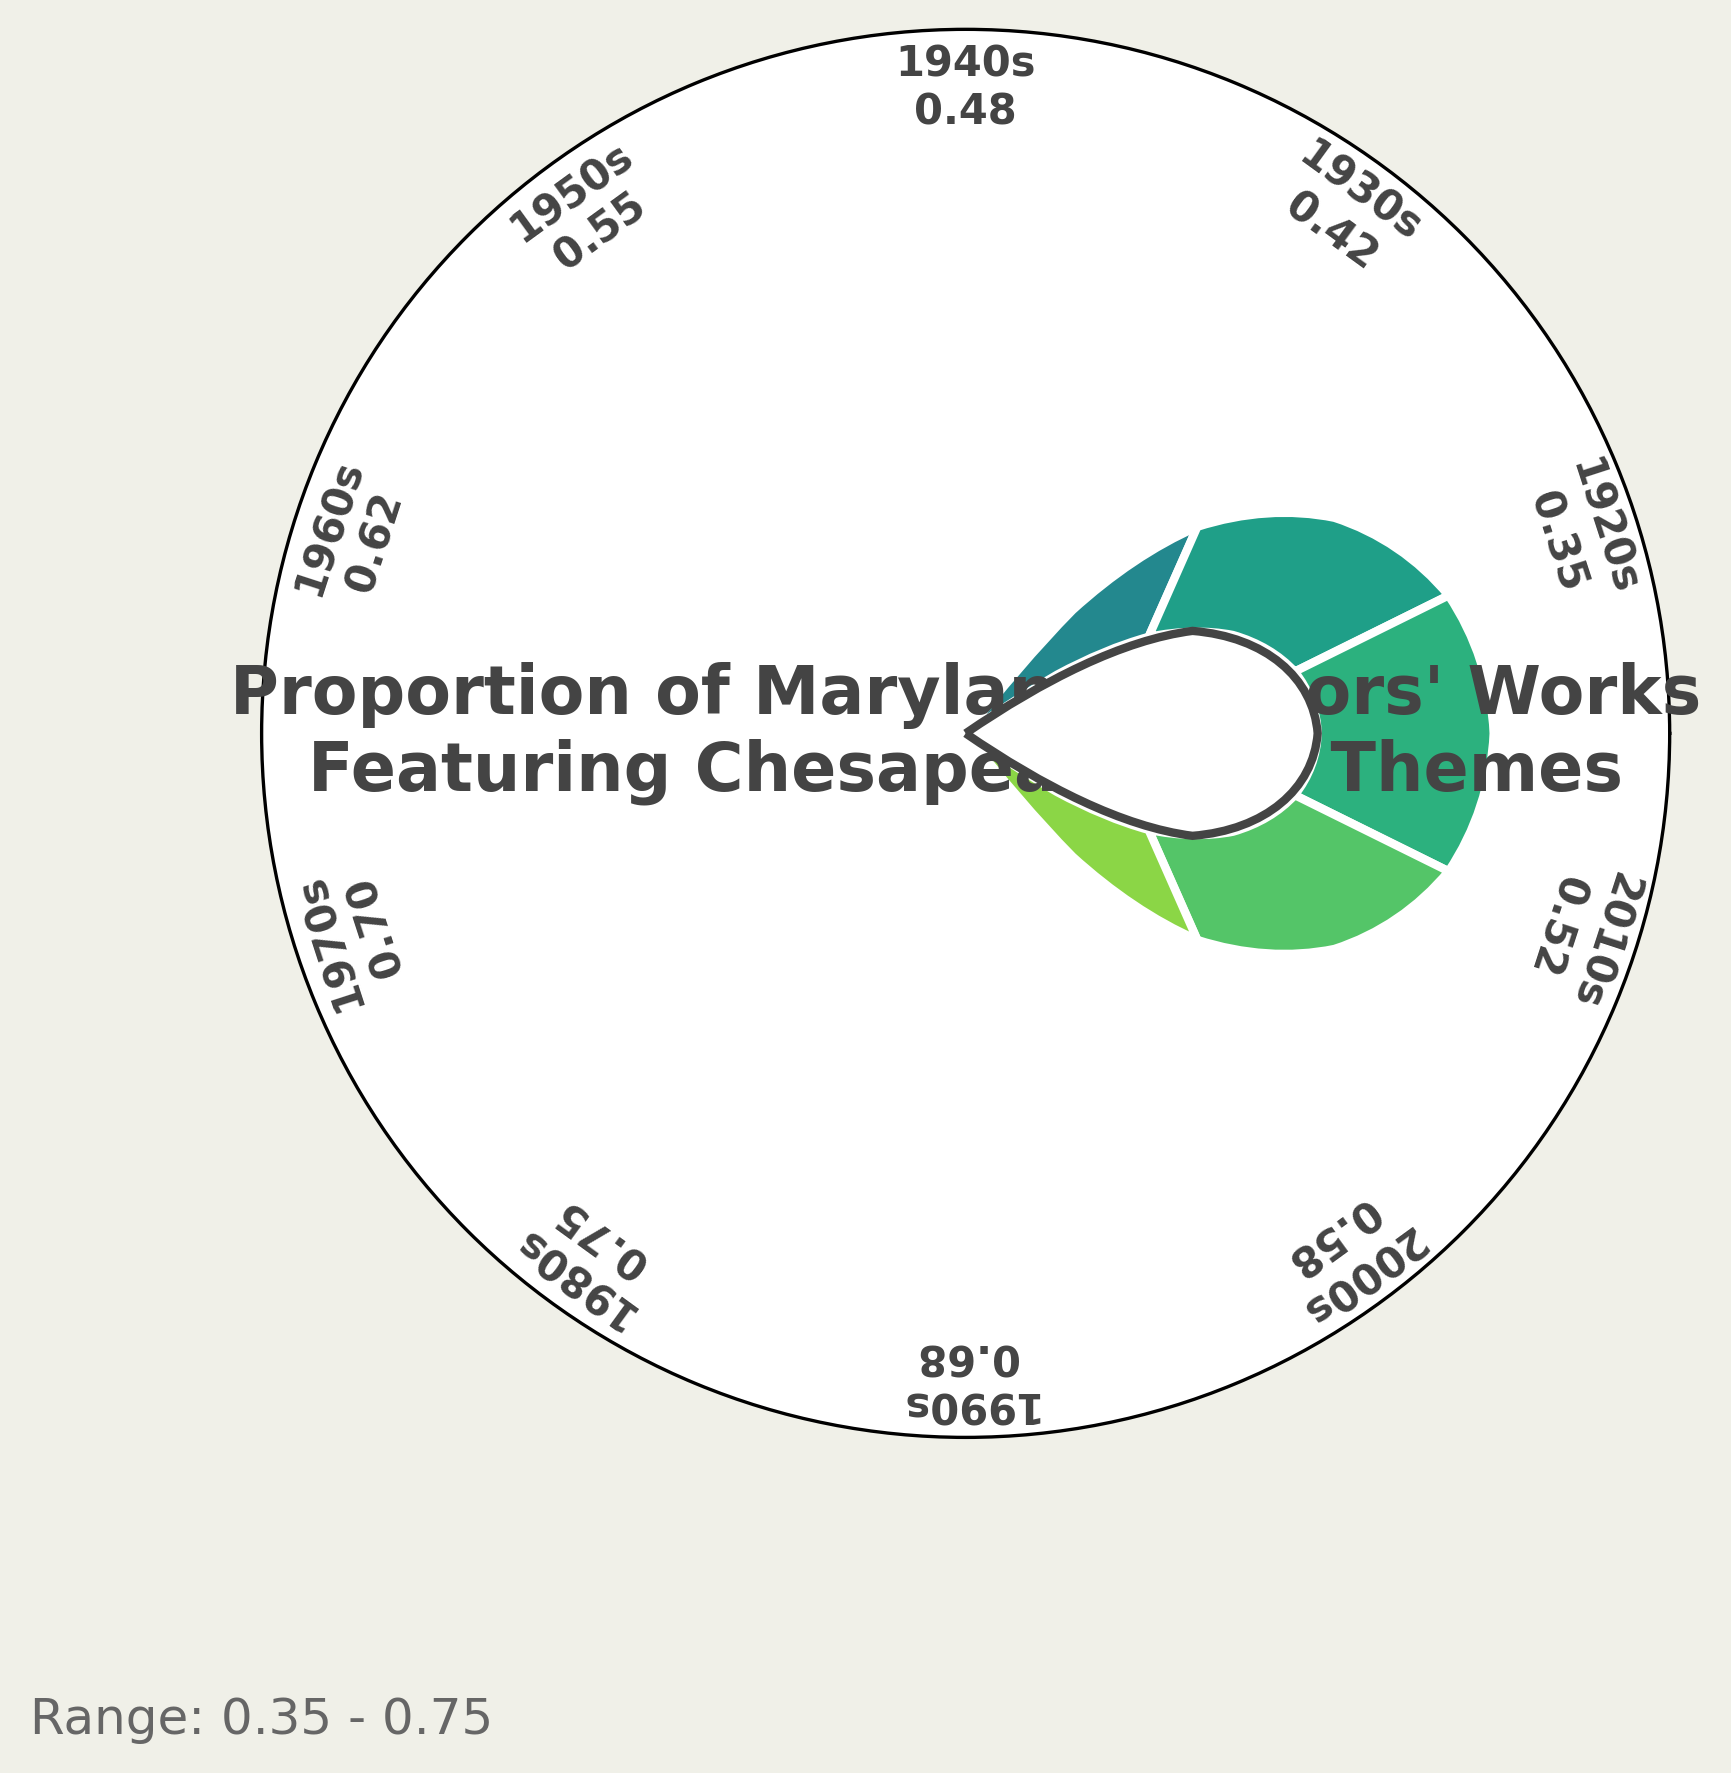What is the title of the figure? The title is usually positioned at the center of the figure to tell what it is about. To find it, look within or near the circular text at the center of the chart.
Answer: Proportion of Maryland Authors' Works Featuring Chesapeake Bay Themes What decade has the highest proportion of works featuring Chesapeake Bay themes? To identify the maximum proportion, compare the numerical values labeled for each decade. The highest numerical value will correspond to the decade with the highest proportion.
Answer: 1980s What color does the proportion for the 1970s appear in? The color associated with a wedge in a gauge chart represents its numerical value. The 1970s wedge proportion appears darker, possibly greenish, based on the color mapping.
Answer: Greenish (dark) What is the range of proportions shown in the figure? Look for the subtitle or legend that usually states the range. Otherwise, compare the minimum and maximum proportions from the labeled values around the chart. The subtitle directly states this information.
Answer: 0.35 - 0.75 How does the proportion in the 1950s compare to the 2010s? Find the label values for both the 1950s and 2010s and compare them. The proportion in the 1950s should be higher or lower based on their numerical comparison.
Answer: Higher What is the average proportion of works featuring Chesapeake Bay themes from the 1960s to the 2000s? Sum the proportions for the 1960s (0.62), 1970s (0.70), 1980s (0.75), 1990s (0.68), and 2000s (0.58). Divide by the number of decades (5). (0.62 + 0.70 + 0.75 + 0.68 + 0.58) / 5 = 3.33 / 5
Answer: 0.67 Are there more decades with proportions greater than or less than 0.50? Count how many decades have a value above 0.50 and how many have below 0.50 by looking at each label. Compare the counts.
Answer: More above 0.50 (6 decades) Which decade saw the largest increase in proportion compared to its previous decade? Calculate the differences in proportions between consecutive decades and identify the largest increase. Compare 1930s-1920s (0.42-0.35), 1940s-1930s (0.48-0.42), 1950s-1940s (0.55-0.48), 1960s-1950s (0.62-0.55), 1970s-1960s (0.70-0.62), 1980s-1970s (0.75-0.70), 1990s-1980s (0.68-0.75), 2000s-1990s (0.58-0.68), 2010s-2000s (0.52-0.58). Largest increase between 1980s and 1970s.
Answer: 1980s What's the median proportion value, and which decade corresponds to it? Arrange all the proportions in ascending order: [0.35, 0.42, 0.48, 0.52, 0.55, 0.58, 0.62, 0.68, 0.70, 0.75]. Median is the middle value in an ordered list. Here, with an even number of data points, it’s the average of the two central numbers (0.55 + 0.58) / 2. Corresponds closest to the 2000s value.
Answer: 0.565, 2000s 